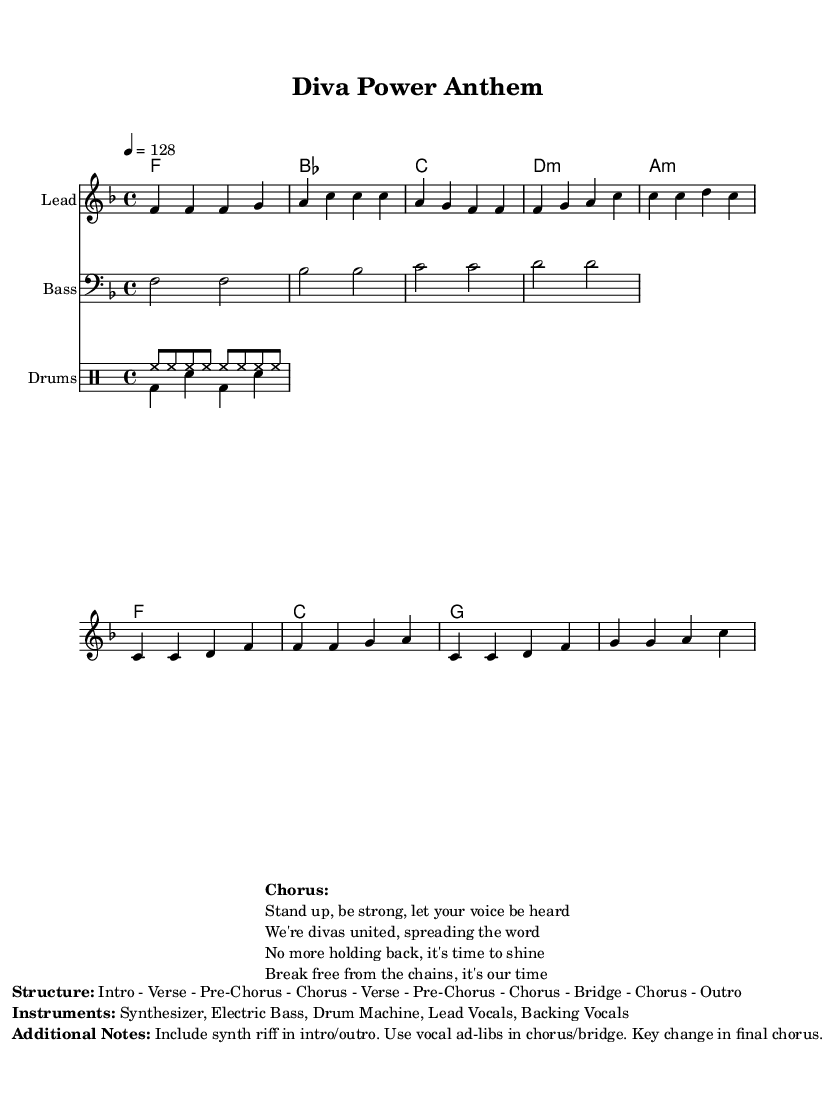What is the key signature of this music? The key signature indicated is F major, which has one flat (B flat). This is typically located at the beginning of the staff as part of the notation.
Answer: F major What is the time signature of this music? The time signature shown is 4/4, which means there are four beats in each measure and the quarter note gets one beat. This can be identified at the beginning of the piece, listed before the clef sign.
Answer: 4/4 What is the tempo marking for this composition? The tempo marking states "4 = 128," which means the piece should be played at a speed of 128 beats per minute with the quarter note receiving one beat. This is located near the beginning, part of the global settings of the score.
Answer: 128 How many sections does this music have? The sheet music marks the structure as "Intro - Verse - Pre-Chorus - Chorus - Verse - Pre-Chorus - Chorus - Bridge - Chorus - Outro," indicating a total of ten distinct sections. This can be directly referenced in the additional notes section of the markup.
Answer: 10 What instruments are used in this piece? The instruments listed include synthesizer, electric bass, drum machine, lead vocals, and backing vocals. This information can be found in the `Instruments` section of the additional notes markup.
Answer: Synthesizer, Electric Bass, Drum Machine, Lead Vocals, Backing Vocals What is the primary theme expressed in the chorus? The chorus expresses empowerment and unity, as seen in the lyrics: "Stand up, be strong, let your voice be heard." This indicates a theme of strength and assertiveness, emphasized in the repeated phrases throughout the section.
Answer: Empowerment How is the bassline structured throughout the piece? The bassline is structured to follow the notes given in the bass staff, reflecting the root notes of the harmonies through consistent rhythmic patterns, primarily using half notes. This structure can be seen in the bassline staff clearly laid out in the music.
Answer: Root notes in half notes 